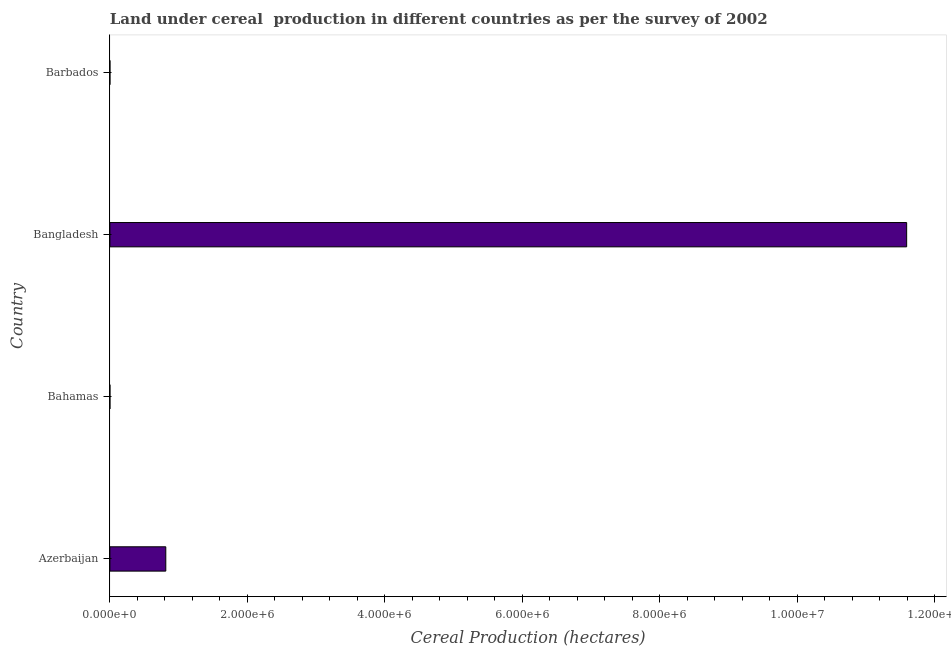Does the graph contain any zero values?
Your answer should be compact. No. What is the title of the graph?
Keep it short and to the point. Land under cereal  production in different countries as per the survey of 2002. What is the label or title of the X-axis?
Provide a succinct answer. Cereal Production (hectares). What is the label or title of the Y-axis?
Your answer should be very brief. Country. What is the land under cereal production in Bangladesh?
Your answer should be very brief. 1.16e+07. Across all countries, what is the maximum land under cereal production?
Give a very brief answer. 1.16e+07. Across all countries, what is the minimum land under cereal production?
Ensure brevity in your answer.  83. In which country was the land under cereal production minimum?
Your answer should be compact. Barbados. What is the sum of the land under cereal production?
Provide a short and direct response. 1.24e+07. What is the difference between the land under cereal production in Bahamas and Barbados?
Provide a succinct answer. 17. What is the average land under cereal production per country?
Make the answer very short. 3.10e+06. What is the median land under cereal production?
Your response must be concise. 4.07e+05. In how many countries, is the land under cereal production greater than 10000000 hectares?
Keep it short and to the point. 1. What is the ratio of the land under cereal production in Azerbaijan to that in Bangladesh?
Provide a short and direct response. 0.07. What is the difference between the highest and the second highest land under cereal production?
Give a very brief answer. 1.08e+07. Is the sum of the land under cereal production in Bahamas and Barbados greater than the maximum land under cereal production across all countries?
Ensure brevity in your answer.  No. What is the difference between the highest and the lowest land under cereal production?
Provide a succinct answer. 1.16e+07. What is the difference between two consecutive major ticks on the X-axis?
Your answer should be compact. 2.00e+06. Are the values on the major ticks of X-axis written in scientific E-notation?
Provide a succinct answer. Yes. What is the Cereal Production (hectares) in Azerbaijan?
Give a very brief answer. 8.13e+05. What is the Cereal Production (hectares) in Bangladesh?
Give a very brief answer. 1.16e+07. What is the difference between the Cereal Production (hectares) in Azerbaijan and Bahamas?
Your response must be concise. 8.13e+05. What is the difference between the Cereal Production (hectares) in Azerbaijan and Bangladesh?
Give a very brief answer. -1.08e+07. What is the difference between the Cereal Production (hectares) in Azerbaijan and Barbados?
Your response must be concise. 8.13e+05. What is the difference between the Cereal Production (hectares) in Bahamas and Bangladesh?
Keep it short and to the point. -1.16e+07. What is the difference between the Cereal Production (hectares) in Bahamas and Barbados?
Ensure brevity in your answer.  17. What is the difference between the Cereal Production (hectares) in Bangladesh and Barbados?
Keep it short and to the point. 1.16e+07. What is the ratio of the Cereal Production (hectares) in Azerbaijan to that in Bahamas?
Your answer should be compact. 8131.91. What is the ratio of the Cereal Production (hectares) in Azerbaijan to that in Bangladesh?
Provide a short and direct response. 0.07. What is the ratio of the Cereal Production (hectares) in Azerbaijan to that in Barbados?
Offer a very short reply. 9797.48. What is the ratio of the Cereal Production (hectares) in Bahamas to that in Barbados?
Ensure brevity in your answer.  1.21. What is the ratio of the Cereal Production (hectares) in Bangladesh to that in Barbados?
Your answer should be very brief. 1.40e+05. 